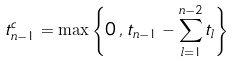Convert formula to latex. <formula><loc_0><loc_0><loc_500><loc_500>t ^ { c } _ { n - 1 } = \max \left \{ 0 \, , \, t _ { n - 1 } - \sum _ { l = 1 } ^ { n - 2 } t _ { l } \right \}</formula> 